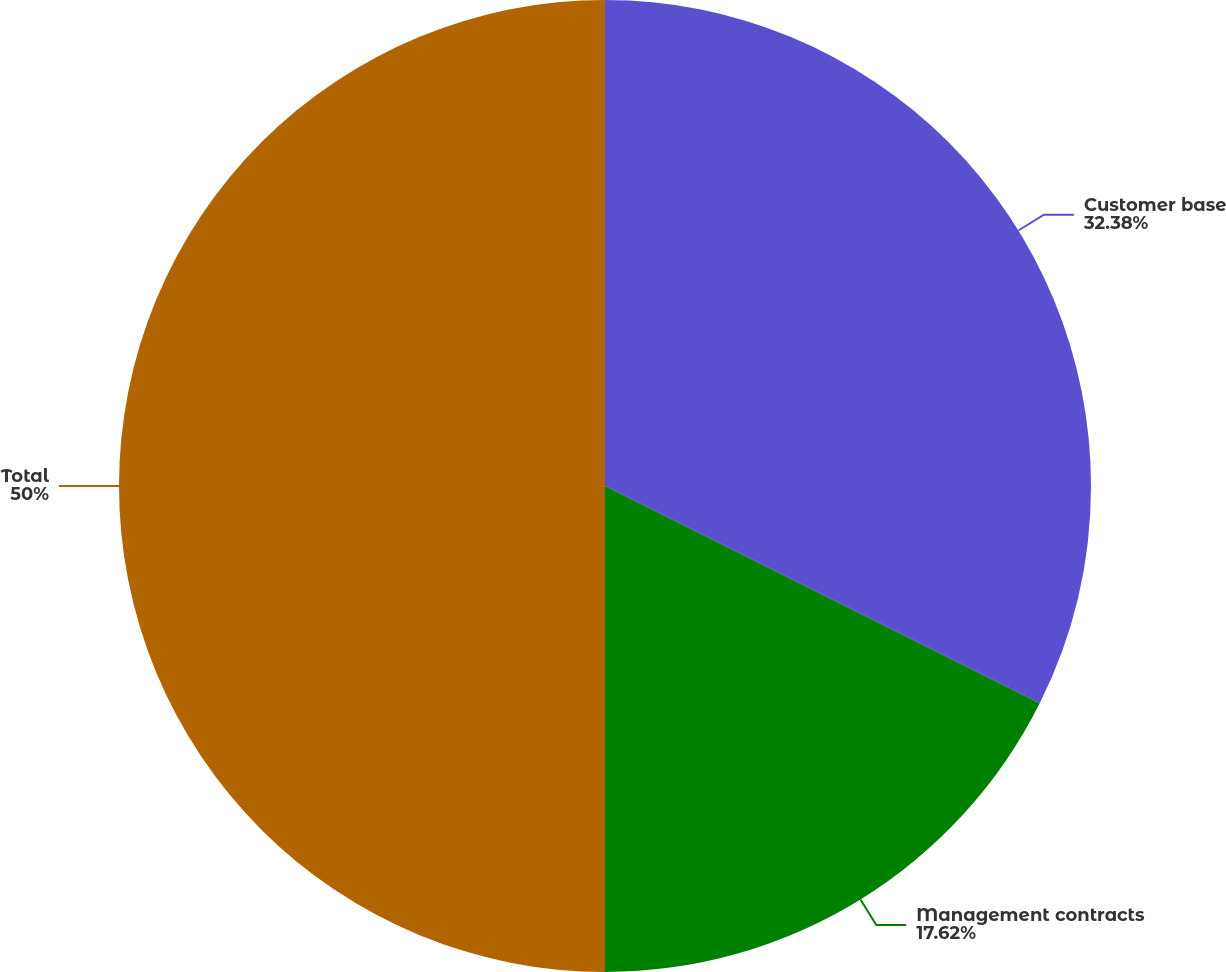<chart> <loc_0><loc_0><loc_500><loc_500><pie_chart><fcel>Customer base<fcel>Management contracts<fcel>Total<nl><fcel>32.38%<fcel>17.62%<fcel>50.0%<nl></chart> 